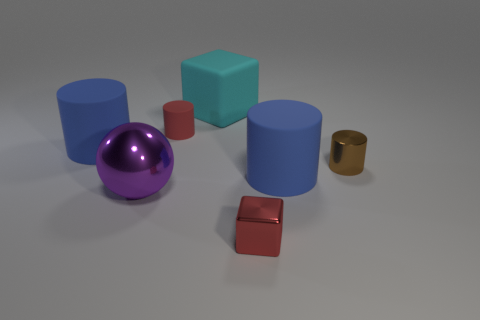Is there any other thing that is the same shape as the large purple object?
Offer a terse response. No. What shape is the brown object?
Keep it short and to the point. Cylinder. Is the number of metal objects to the left of the tiny brown metallic cylinder greater than the number of large purple metallic things?
Make the answer very short. Yes. There is a red object that is on the right side of the cyan rubber object; what is its shape?
Ensure brevity in your answer.  Cube. What number of other objects are there of the same shape as the big purple metal object?
Your answer should be very brief. 0. Is the material of the big blue object in front of the brown cylinder the same as the cyan block?
Your answer should be very brief. Yes. Are there an equal number of large rubber blocks behind the rubber block and red metal cubes behind the purple shiny sphere?
Keep it short and to the point. Yes. What is the size of the rubber cylinder that is in front of the brown thing?
Give a very brief answer. Large. Are there any other cyan cubes made of the same material as the tiny cube?
Offer a terse response. No. Do the thing behind the tiny rubber cylinder and the large shiny ball have the same color?
Your response must be concise. No. 